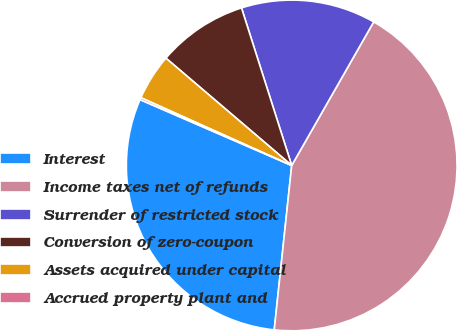Convert chart. <chart><loc_0><loc_0><loc_500><loc_500><pie_chart><fcel>Interest<fcel>Income taxes net of refunds<fcel>Surrender of restricted stock<fcel>Conversion of zero-coupon<fcel>Assets acquired under capital<fcel>Accrued property plant and<nl><fcel>29.84%<fcel>43.43%<fcel>13.17%<fcel>8.85%<fcel>4.52%<fcel>0.2%<nl></chart> 